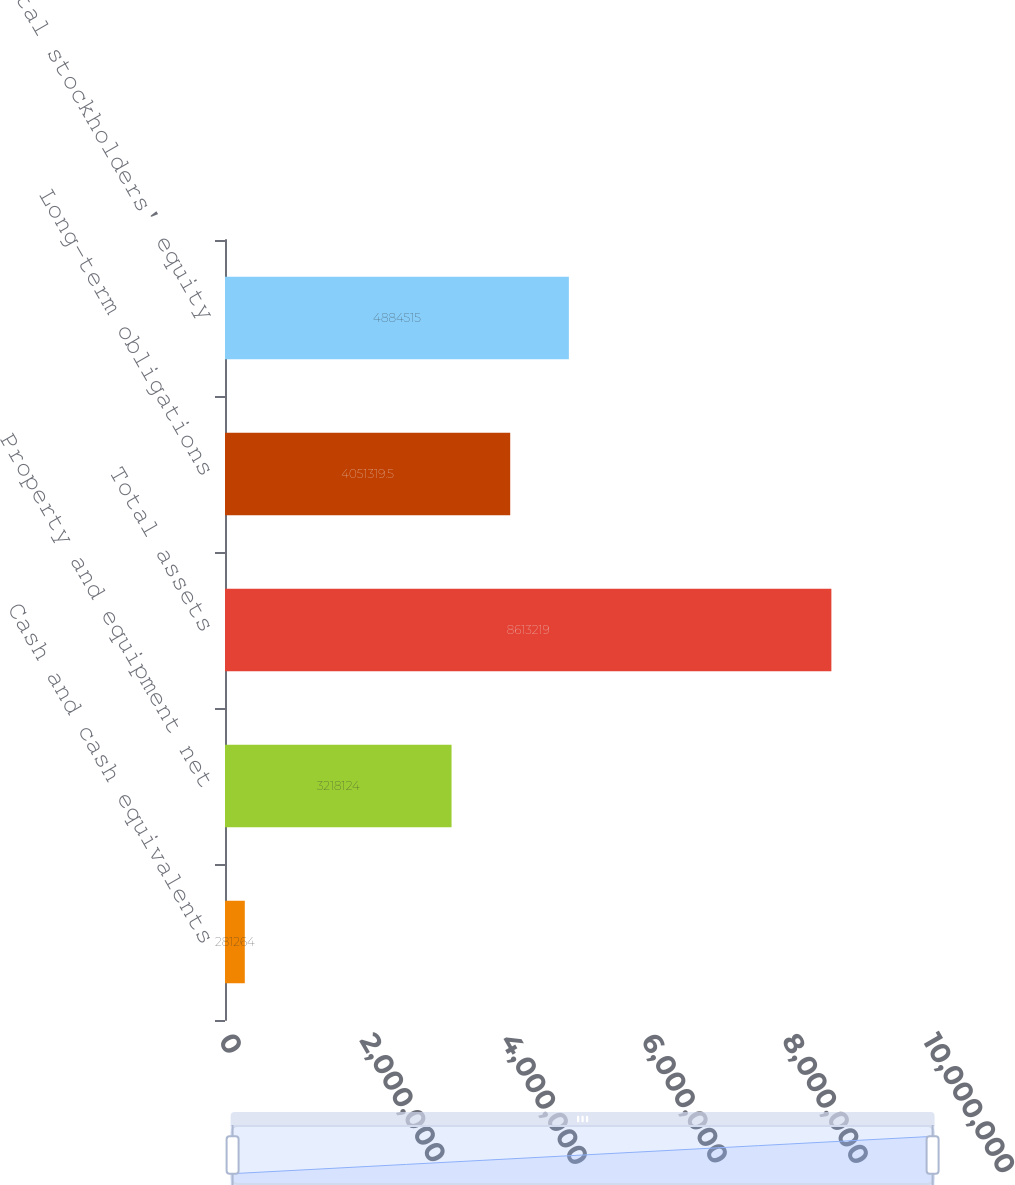Convert chart to OTSL. <chart><loc_0><loc_0><loc_500><loc_500><bar_chart><fcel>Cash and cash equivalents<fcel>Property and equipment net<fcel>Total assets<fcel>Long-term obligations<fcel>Total stockholders' equity<nl><fcel>281264<fcel>3.21812e+06<fcel>8.61322e+06<fcel>4.05132e+06<fcel>4.88452e+06<nl></chart> 